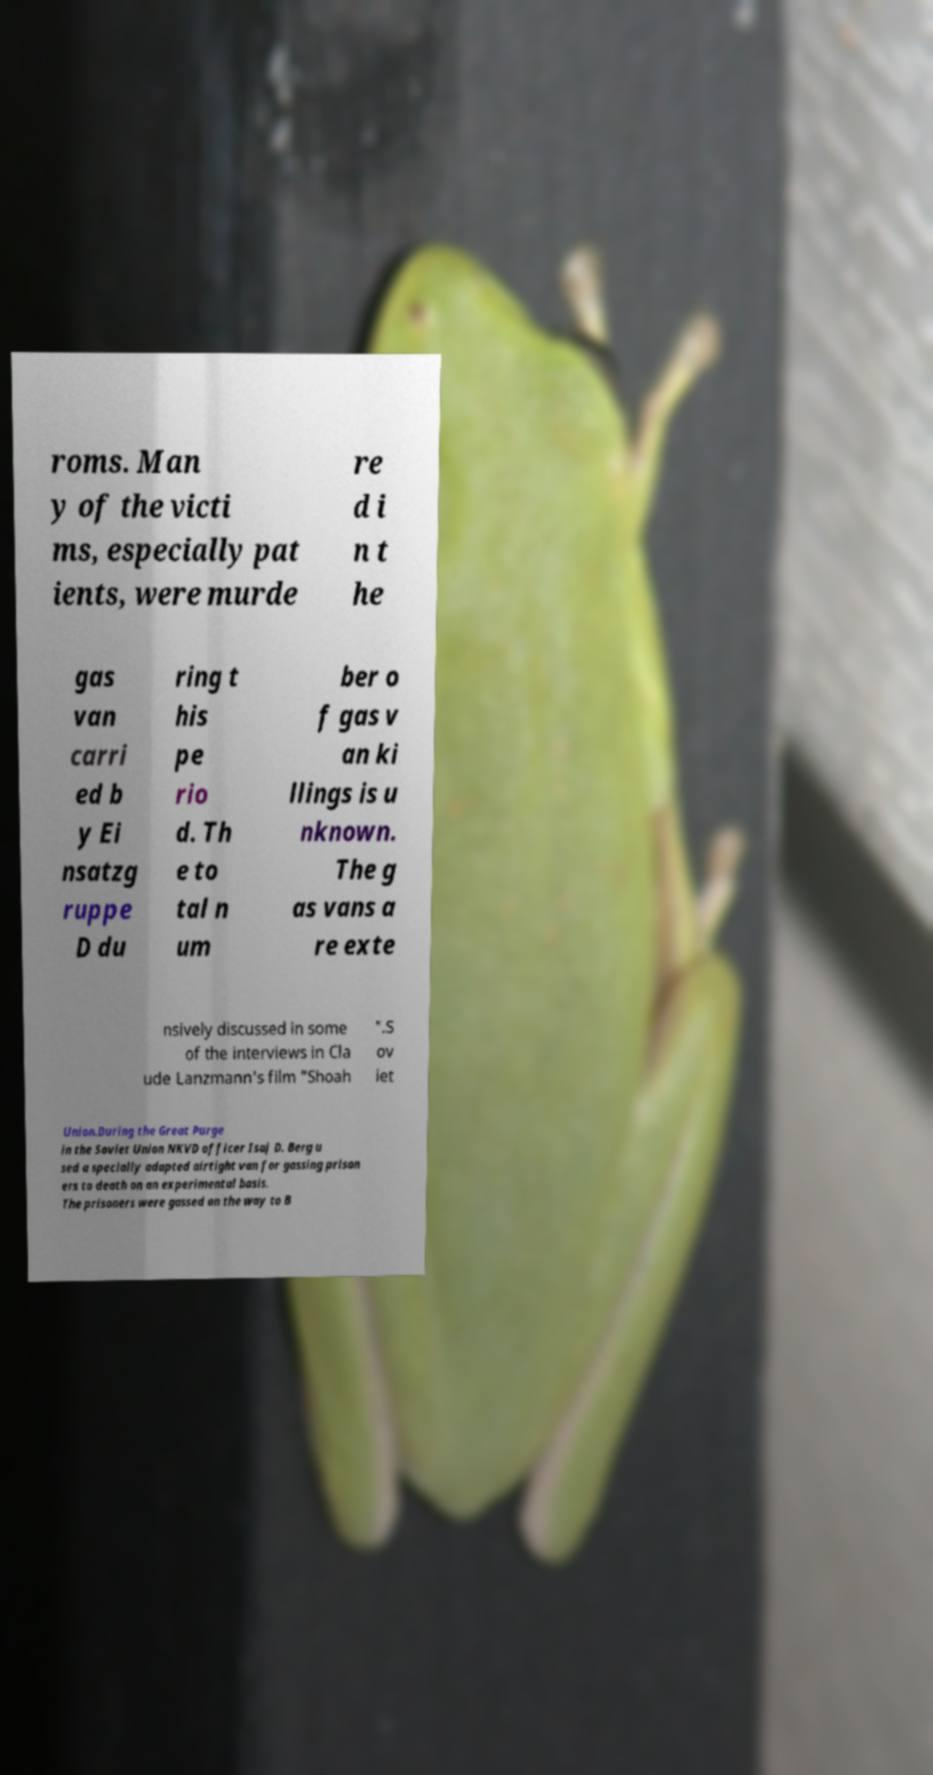I need the written content from this picture converted into text. Can you do that? roms. Man y of the victi ms, especially pat ients, were murde re d i n t he gas van carri ed b y Ei nsatzg ruppe D du ring t his pe rio d. Th e to tal n um ber o f gas v an ki llings is u nknown. The g as vans a re exte nsively discussed in some of the interviews in Cla ude Lanzmann's film "Shoah ".S ov iet Union.During the Great Purge in the Soviet Union NKVD officer Isaj D. Berg u sed a specially adapted airtight van for gassing prison ers to death on an experimental basis. The prisoners were gassed on the way to B 